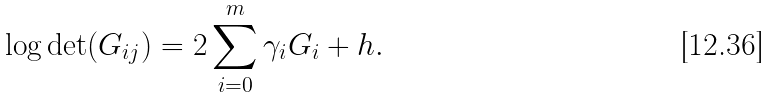Convert formula to latex. <formula><loc_0><loc_0><loc_500><loc_500>\log \det ( G _ { i j } ) = 2 \sum _ { i = 0 } ^ { m } \gamma _ { i } G _ { i } + h .</formula> 